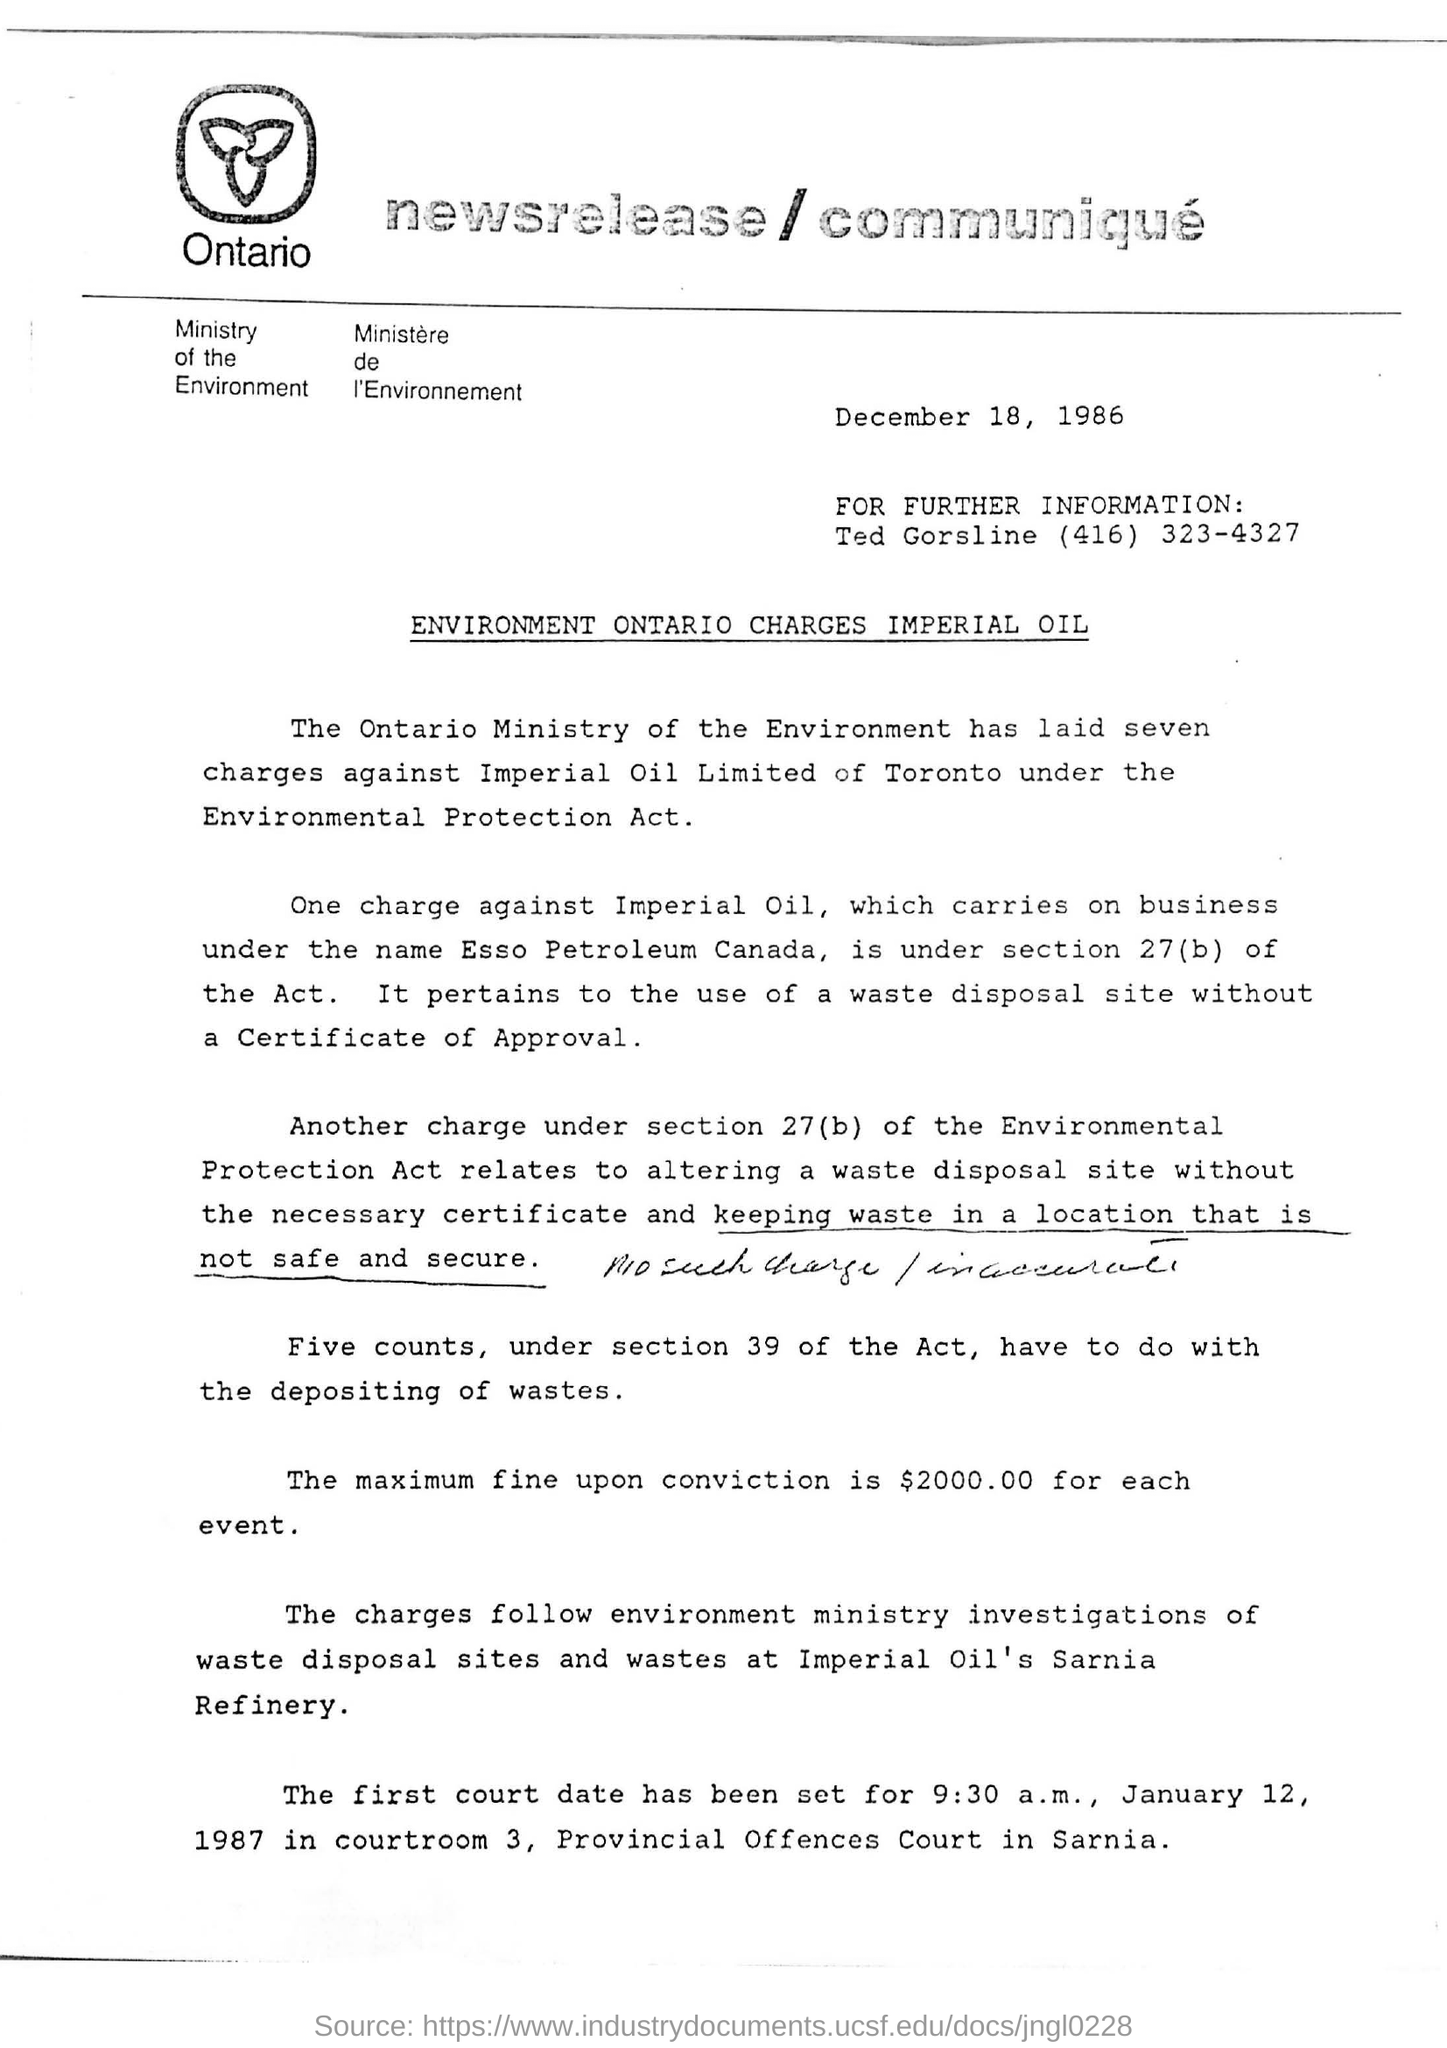What is maximum fine upon the conviction?
Provide a short and direct response. $2000.00 FOR EACH EVENT. How many charges laid by Ontario ministry?
Provide a succinct answer. SEVEN. Which country is Esso petroleum located at?
Your answer should be compact. Canada. 